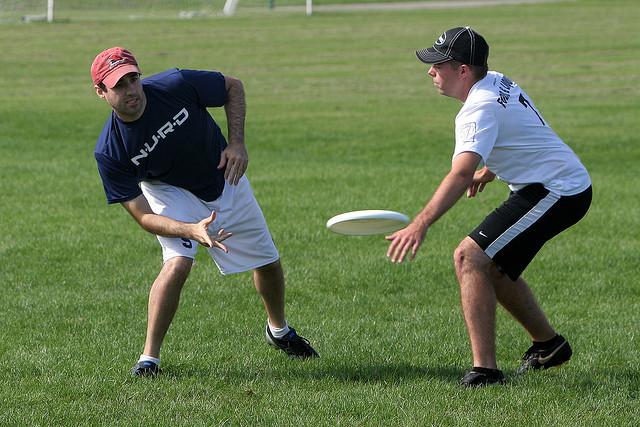Are they both wearing caps?
Be succinct. Yes. Is the guy in the dark blue shirt trying to hard?
Answer briefly. No. Are both men wearing watches?
Keep it brief. No. What type of hats are the men wearing?
Write a very short answer. Baseball. What are they throwing?
Short answer required. Frisbee. 